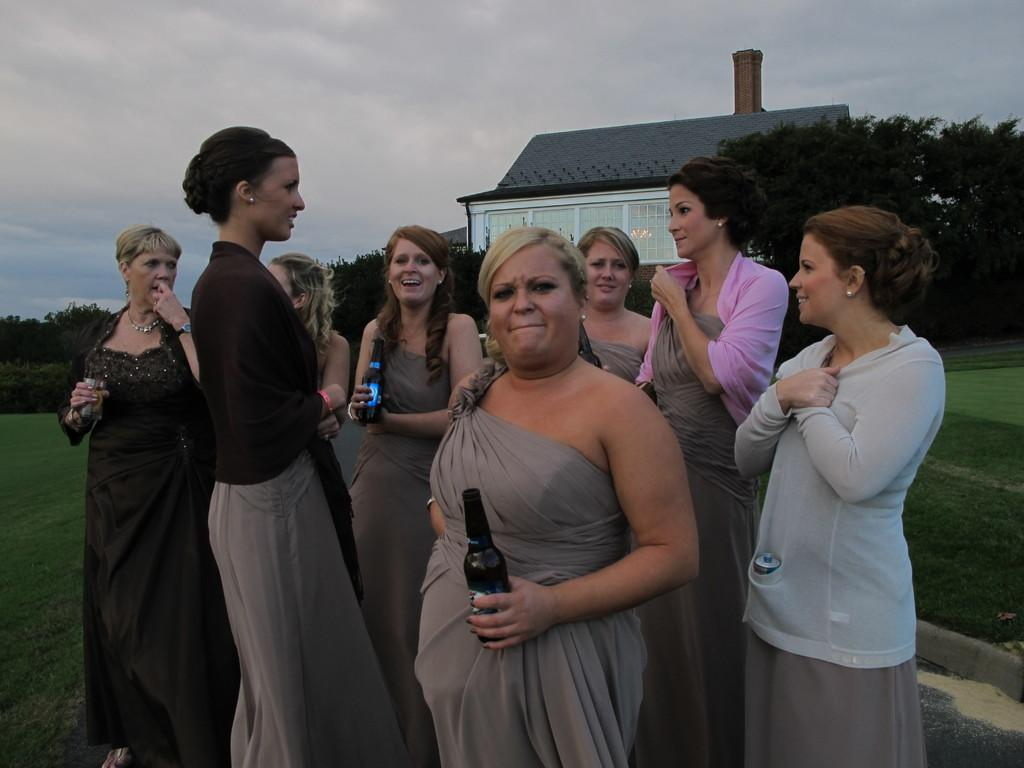What are the women in the image holding? The women are holding bottles in the image. What type of terrain is visible in the image? There is grass visible in the image. What can be seen in the background of the image? There are trees, a house, and the sky visible in the background of the image. What is the condition of the sky in the image? The sky is visible in the background of the image, and clouds are present. What type of chin can be seen on the potato in the image? There is no potato present in the image, and therefore no chin can be observed. How are the women attempting to balance the bottles in the image? The image does not show the women attempting to balance the bottles; they are simply holding them. 